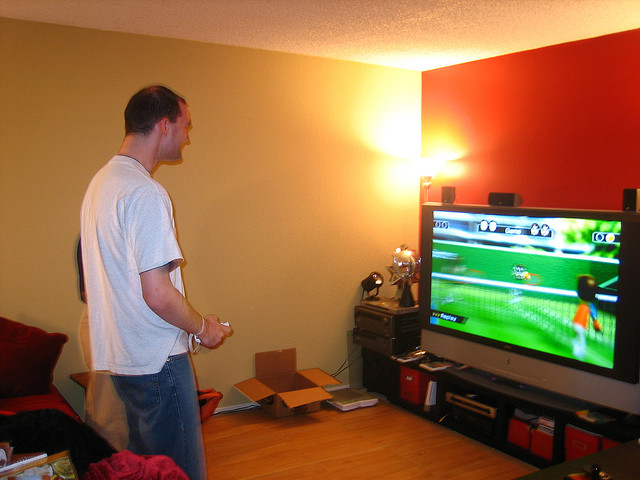<image>What is the team logo on the TV? I don't know what the team logo on the TV is. It is unclear and cannot be seen. What is the team logo on the TV? I am not sure what the team logo on the TV is. It can be either 'wii', 'broncos', 'swoosh', 'orange', 'no logo', 'your best guess', 'unclear' or 'not sure'. 